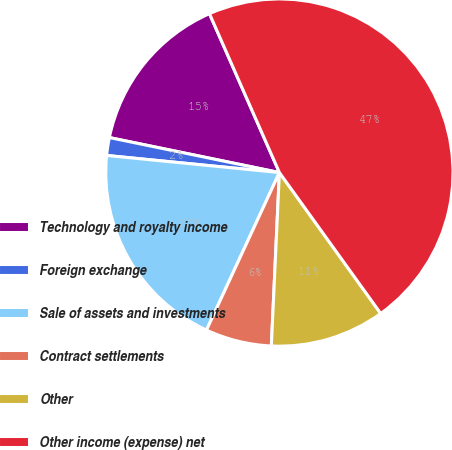<chart> <loc_0><loc_0><loc_500><loc_500><pie_chart><fcel>Technology and royalty income<fcel>Foreign exchange<fcel>Sale of assets and investments<fcel>Contract settlements<fcel>Other<fcel>Other income (expense) net<nl><fcel>15.17%<fcel>1.66%<fcel>19.67%<fcel>6.16%<fcel>10.66%<fcel>46.68%<nl></chart> 